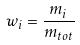Convert formula to latex. <formula><loc_0><loc_0><loc_500><loc_500>w _ { i } = \frac { m _ { i } } { m _ { t o t } }</formula> 